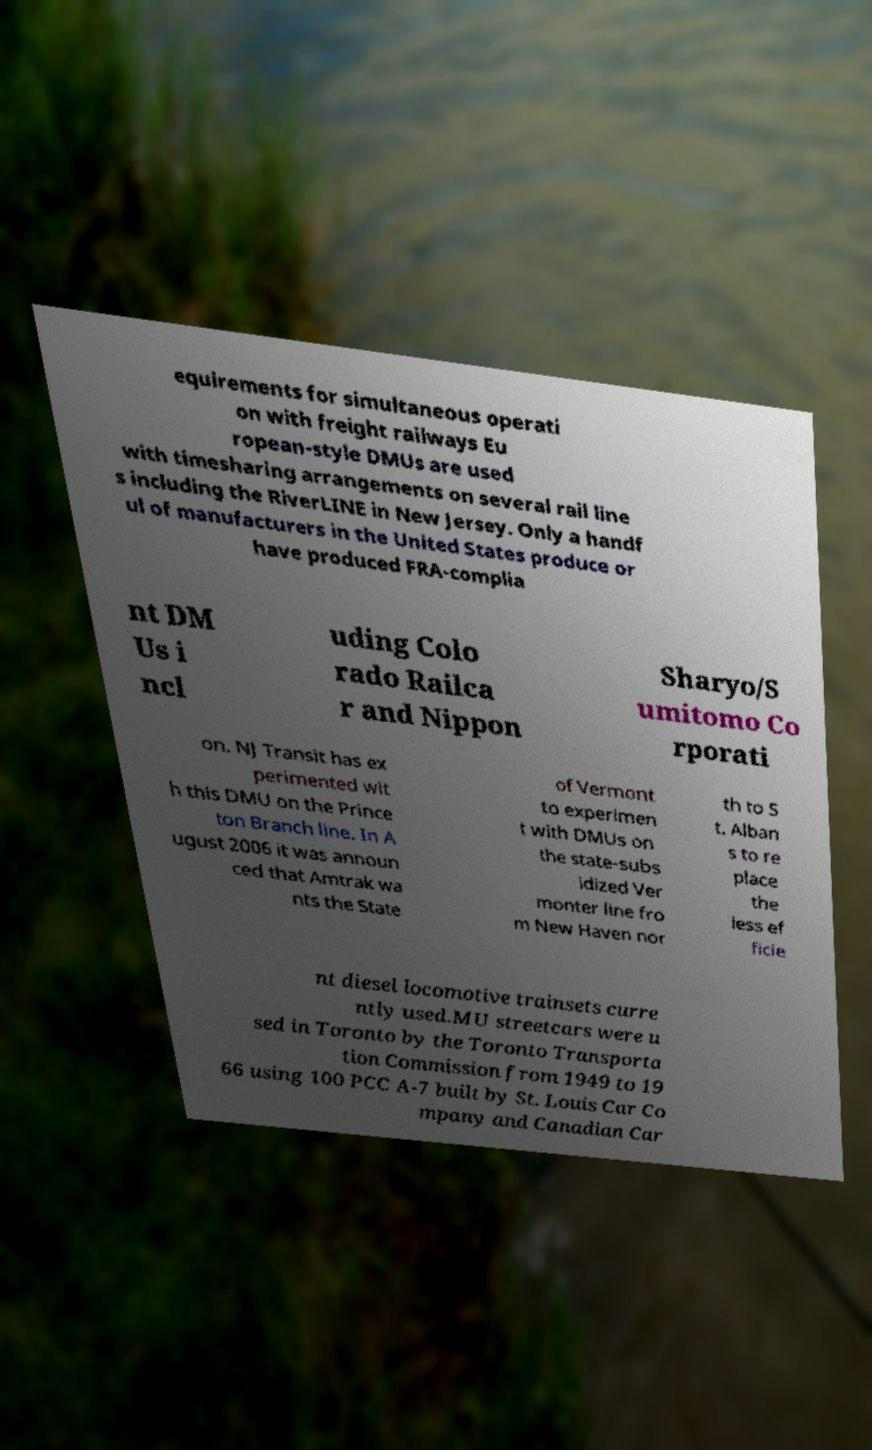I need the written content from this picture converted into text. Can you do that? equirements for simultaneous operati on with freight railways Eu ropean-style DMUs are used with timesharing arrangements on several rail line s including the RiverLINE in New Jersey. Only a handf ul of manufacturers in the United States produce or have produced FRA-complia nt DM Us i ncl uding Colo rado Railca r and Nippon Sharyo/S umitomo Co rporati on. NJ Transit has ex perimented wit h this DMU on the Prince ton Branch line. In A ugust 2006 it was announ ced that Amtrak wa nts the State of Vermont to experimen t with DMUs on the state-subs idized Ver monter line fro m New Haven nor th to S t. Alban s to re place the less ef ficie nt diesel locomotive trainsets curre ntly used.MU streetcars were u sed in Toronto by the Toronto Transporta tion Commission from 1949 to 19 66 using 100 PCC A-7 built by St. Louis Car Co mpany and Canadian Car 